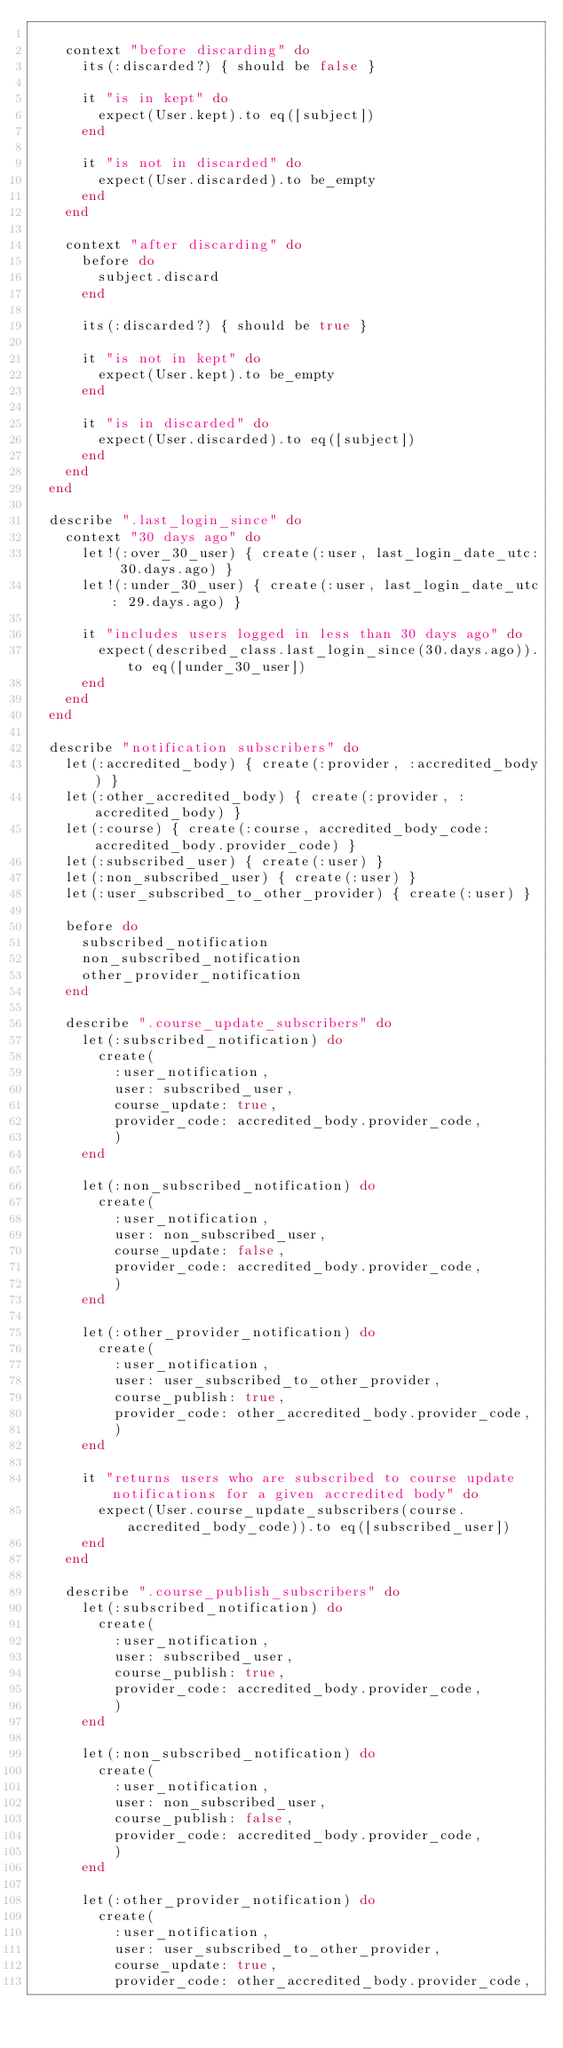Convert code to text. <code><loc_0><loc_0><loc_500><loc_500><_Ruby_>
    context "before discarding" do
      its(:discarded?) { should be false }

      it "is in kept" do
        expect(User.kept).to eq([subject])
      end

      it "is not in discarded" do
        expect(User.discarded).to be_empty
      end
    end

    context "after discarding" do
      before do
        subject.discard
      end

      its(:discarded?) { should be true }

      it "is not in kept" do
        expect(User.kept).to be_empty
      end

      it "is in discarded" do
        expect(User.discarded).to eq([subject])
      end
    end
  end

  describe ".last_login_since" do
    context "30 days ago" do
      let!(:over_30_user) { create(:user, last_login_date_utc: 30.days.ago) }
      let!(:under_30_user) { create(:user, last_login_date_utc: 29.days.ago) }

      it "includes users logged in less than 30 days ago" do
        expect(described_class.last_login_since(30.days.ago)).to eq([under_30_user])
      end
    end
  end

  describe "notification subscribers" do
    let(:accredited_body) { create(:provider, :accredited_body) }
    let(:other_accredited_body) { create(:provider, :accredited_body) }
    let(:course) { create(:course, accredited_body_code: accredited_body.provider_code) }
    let(:subscribed_user) { create(:user) }
    let(:non_subscribed_user) { create(:user) }
    let(:user_subscribed_to_other_provider) { create(:user) }

    before do
      subscribed_notification
      non_subscribed_notification
      other_provider_notification
    end

    describe ".course_update_subscribers" do
      let(:subscribed_notification) do
        create(
          :user_notification,
          user: subscribed_user,
          course_update: true,
          provider_code: accredited_body.provider_code,
          )
      end

      let(:non_subscribed_notification) do
        create(
          :user_notification,
          user: non_subscribed_user,
          course_update: false,
          provider_code: accredited_body.provider_code,
          )
      end

      let(:other_provider_notification) do
        create(
          :user_notification,
          user: user_subscribed_to_other_provider,
          course_publish: true,
          provider_code: other_accredited_body.provider_code,
          )
      end

      it "returns users who are subscribed to course update notifications for a given accredited body" do
        expect(User.course_update_subscribers(course.accredited_body_code)).to eq([subscribed_user])
      end
    end

    describe ".course_publish_subscribers" do
      let(:subscribed_notification) do
        create(
          :user_notification,
          user: subscribed_user,
          course_publish: true,
          provider_code: accredited_body.provider_code,
          )
      end

      let(:non_subscribed_notification) do
        create(
          :user_notification,
          user: non_subscribed_user,
          course_publish: false,
          provider_code: accredited_body.provider_code,
          )
      end

      let(:other_provider_notification) do
        create(
          :user_notification,
          user: user_subscribed_to_other_provider,
          course_update: true,
          provider_code: other_accredited_body.provider_code,</code> 